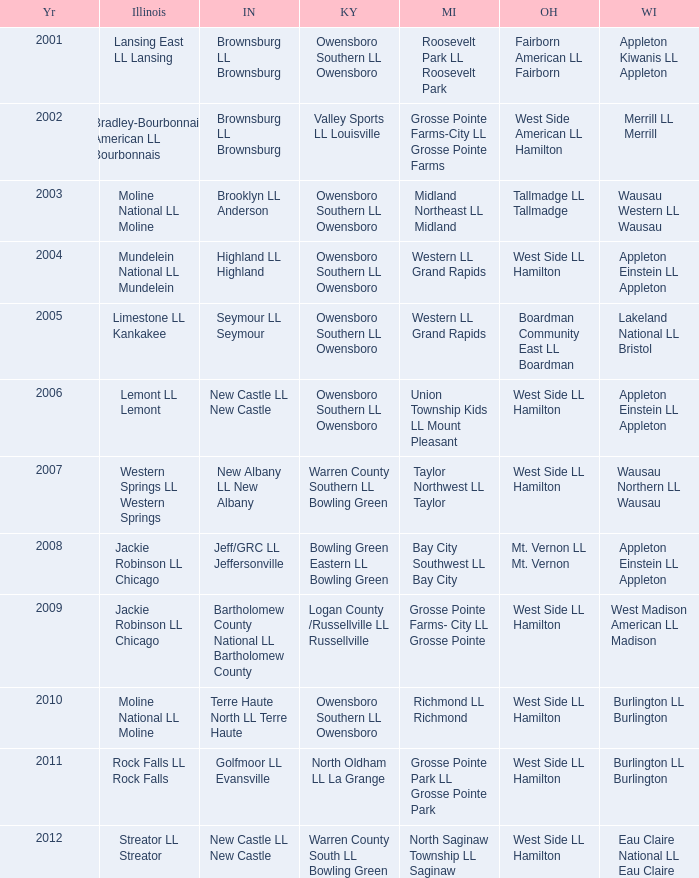What was the little league team from Indiana when the little league team from Michigan was Midland Northeast LL Midland? Brooklyn LL Anderson. 